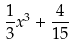<formula> <loc_0><loc_0><loc_500><loc_500>\frac { 1 } { 3 } x ^ { 3 } + \frac { 4 } { 1 5 }</formula> 